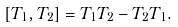Convert formula to latex. <formula><loc_0><loc_0><loc_500><loc_500>[ T _ { 1 } , T _ { 2 } ] = T _ { 1 } T _ { 2 } - T _ { 2 } T _ { 1 } .</formula> 